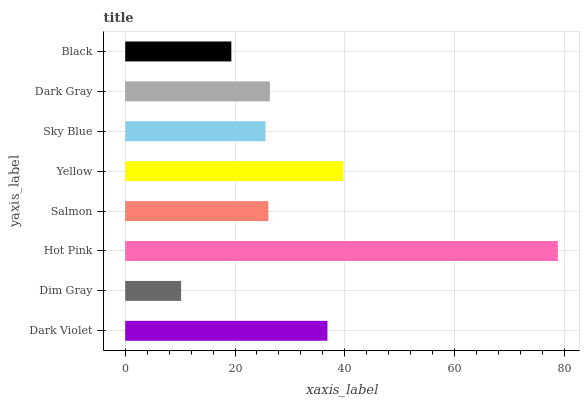Is Dim Gray the minimum?
Answer yes or no. Yes. Is Hot Pink the maximum?
Answer yes or no. Yes. Is Hot Pink the minimum?
Answer yes or no. No. Is Dim Gray the maximum?
Answer yes or no. No. Is Hot Pink greater than Dim Gray?
Answer yes or no. Yes. Is Dim Gray less than Hot Pink?
Answer yes or no. Yes. Is Dim Gray greater than Hot Pink?
Answer yes or no. No. Is Hot Pink less than Dim Gray?
Answer yes or no. No. Is Dark Gray the high median?
Answer yes or no. Yes. Is Salmon the low median?
Answer yes or no. Yes. Is Dim Gray the high median?
Answer yes or no. No. Is Hot Pink the low median?
Answer yes or no. No. 